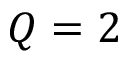<formula> <loc_0><loc_0><loc_500><loc_500>Q = 2</formula> 